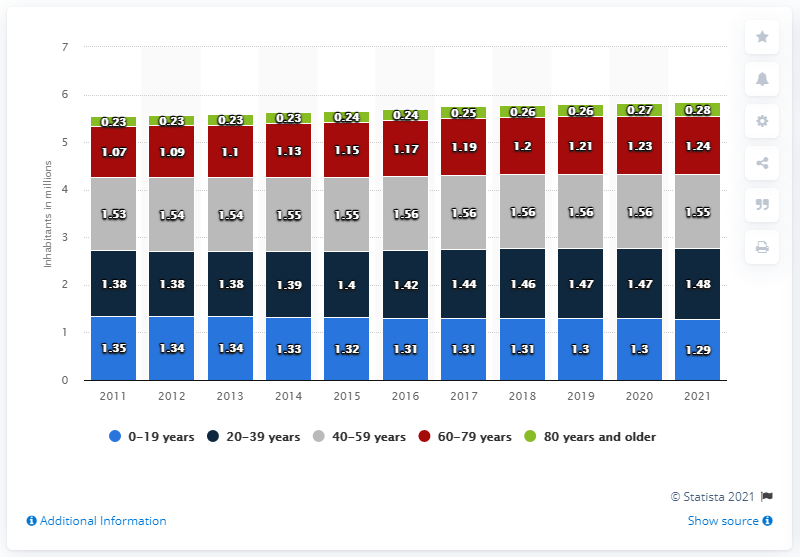Specify some key components in this picture. In 2011, there were approximately 1.55 million people between the ages of 40 and 59. In 2011, approximately 0.23% of the population of Denmark was aged 80 or older. 